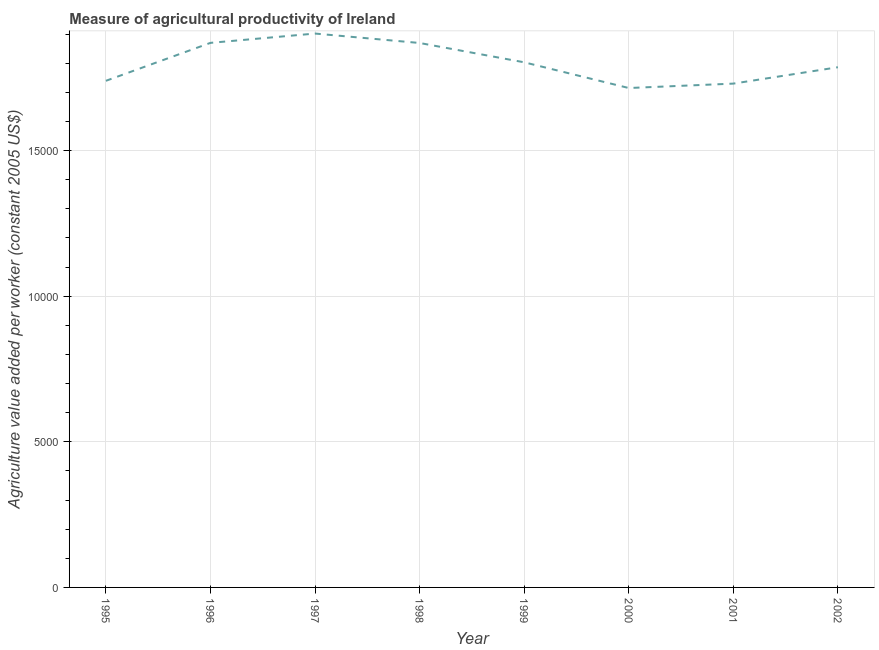What is the agriculture value added per worker in 2000?
Your answer should be compact. 1.71e+04. Across all years, what is the maximum agriculture value added per worker?
Offer a very short reply. 1.90e+04. Across all years, what is the minimum agriculture value added per worker?
Ensure brevity in your answer.  1.71e+04. What is the sum of the agriculture value added per worker?
Offer a very short reply. 1.44e+05. What is the difference between the agriculture value added per worker in 1996 and 2001?
Offer a very short reply. 1399.32. What is the average agriculture value added per worker per year?
Keep it short and to the point. 1.80e+04. What is the median agriculture value added per worker?
Give a very brief answer. 1.79e+04. In how many years, is the agriculture value added per worker greater than 4000 US$?
Offer a terse response. 8. What is the ratio of the agriculture value added per worker in 1996 to that in 1999?
Offer a very short reply. 1.04. Is the agriculture value added per worker in 1995 less than that in 2000?
Provide a succinct answer. No. What is the difference between the highest and the second highest agriculture value added per worker?
Your answer should be very brief. 319.78. Is the sum of the agriculture value added per worker in 2000 and 2002 greater than the maximum agriculture value added per worker across all years?
Offer a terse response. Yes. What is the difference between the highest and the lowest agriculture value added per worker?
Offer a terse response. 1870.44. Are the values on the major ticks of Y-axis written in scientific E-notation?
Ensure brevity in your answer.  No. Does the graph contain any zero values?
Provide a short and direct response. No. What is the title of the graph?
Provide a short and direct response. Measure of agricultural productivity of Ireland. What is the label or title of the X-axis?
Give a very brief answer. Year. What is the label or title of the Y-axis?
Your answer should be compact. Agriculture value added per worker (constant 2005 US$). What is the Agriculture value added per worker (constant 2005 US$) of 1995?
Give a very brief answer. 1.74e+04. What is the Agriculture value added per worker (constant 2005 US$) of 1996?
Ensure brevity in your answer.  1.87e+04. What is the Agriculture value added per worker (constant 2005 US$) in 1997?
Your answer should be very brief. 1.90e+04. What is the Agriculture value added per worker (constant 2005 US$) of 1998?
Your answer should be compact. 1.87e+04. What is the Agriculture value added per worker (constant 2005 US$) of 1999?
Ensure brevity in your answer.  1.80e+04. What is the Agriculture value added per worker (constant 2005 US$) in 2000?
Your response must be concise. 1.71e+04. What is the Agriculture value added per worker (constant 2005 US$) in 2001?
Your answer should be compact. 1.73e+04. What is the Agriculture value added per worker (constant 2005 US$) of 2002?
Offer a terse response. 1.79e+04. What is the difference between the Agriculture value added per worker (constant 2005 US$) in 1995 and 1996?
Your answer should be compact. -1303.08. What is the difference between the Agriculture value added per worker (constant 2005 US$) in 1995 and 1997?
Make the answer very short. -1622.86. What is the difference between the Agriculture value added per worker (constant 2005 US$) in 1995 and 1998?
Make the answer very short. -1298.7. What is the difference between the Agriculture value added per worker (constant 2005 US$) in 1995 and 1999?
Your answer should be compact. -635.52. What is the difference between the Agriculture value added per worker (constant 2005 US$) in 1995 and 2000?
Offer a terse response. 247.58. What is the difference between the Agriculture value added per worker (constant 2005 US$) in 1995 and 2001?
Your answer should be compact. 96.24. What is the difference between the Agriculture value added per worker (constant 2005 US$) in 1995 and 2002?
Give a very brief answer. -466.16. What is the difference between the Agriculture value added per worker (constant 2005 US$) in 1996 and 1997?
Keep it short and to the point. -319.78. What is the difference between the Agriculture value added per worker (constant 2005 US$) in 1996 and 1998?
Your answer should be compact. 4.38. What is the difference between the Agriculture value added per worker (constant 2005 US$) in 1996 and 1999?
Give a very brief answer. 667.56. What is the difference between the Agriculture value added per worker (constant 2005 US$) in 1996 and 2000?
Keep it short and to the point. 1550.66. What is the difference between the Agriculture value added per worker (constant 2005 US$) in 1996 and 2001?
Make the answer very short. 1399.32. What is the difference between the Agriculture value added per worker (constant 2005 US$) in 1996 and 2002?
Your response must be concise. 836.92. What is the difference between the Agriculture value added per worker (constant 2005 US$) in 1997 and 1998?
Provide a short and direct response. 324.17. What is the difference between the Agriculture value added per worker (constant 2005 US$) in 1997 and 1999?
Give a very brief answer. 987.34. What is the difference between the Agriculture value added per worker (constant 2005 US$) in 1997 and 2000?
Provide a succinct answer. 1870.44. What is the difference between the Agriculture value added per worker (constant 2005 US$) in 1997 and 2001?
Your answer should be compact. 1719.1. What is the difference between the Agriculture value added per worker (constant 2005 US$) in 1997 and 2002?
Provide a succinct answer. 1156.7. What is the difference between the Agriculture value added per worker (constant 2005 US$) in 1998 and 1999?
Offer a very short reply. 663.18. What is the difference between the Agriculture value added per worker (constant 2005 US$) in 1998 and 2000?
Make the answer very short. 1546.27. What is the difference between the Agriculture value added per worker (constant 2005 US$) in 1998 and 2001?
Your response must be concise. 1394.93. What is the difference between the Agriculture value added per worker (constant 2005 US$) in 1998 and 2002?
Your response must be concise. 832.54. What is the difference between the Agriculture value added per worker (constant 2005 US$) in 1999 and 2000?
Offer a terse response. 883.1. What is the difference between the Agriculture value added per worker (constant 2005 US$) in 1999 and 2001?
Keep it short and to the point. 731.76. What is the difference between the Agriculture value added per worker (constant 2005 US$) in 1999 and 2002?
Your answer should be very brief. 169.36. What is the difference between the Agriculture value added per worker (constant 2005 US$) in 2000 and 2001?
Offer a terse response. -151.34. What is the difference between the Agriculture value added per worker (constant 2005 US$) in 2000 and 2002?
Your response must be concise. -713.73. What is the difference between the Agriculture value added per worker (constant 2005 US$) in 2001 and 2002?
Make the answer very short. -562.4. What is the ratio of the Agriculture value added per worker (constant 2005 US$) in 1995 to that in 1996?
Your answer should be very brief. 0.93. What is the ratio of the Agriculture value added per worker (constant 2005 US$) in 1995 to that in 1997?
Offer a terse response. 0.92. What is the ratio of the Agriculture value added per worker (constant 2005 US$) in 1995 to that in 1999?
Provide a succinct answer. 0.96. What is the ratio of the Agriculture value added per worker (constant 2005 US$) in 1995 to that in 2000?
Your answer should be compact. 1.01. What is the ratio of the Agriculture value added per worker (constant 2005 US$) in 1995 to that in 2001?
Make the answer very short. 1.01. What is the ratio of the Agriculture value added per worker (constant 2005 US$) in 1996 to that in 1998?
Your response must be concise. 1. What is the ratio of the Agriculture value added per worker (constant 2005 US$) in 1996 to that in 2000?
Provide a succinct answer. 1.09. What is the ratio of the Agriculture value added per worker (constant 2005 US$) in 1996 to that in 2001?
Offer a very short reply. 1.08. What is the ratio of the Agriculture value added per worker (constant 2005 US$) in 1996 to that in 2002?
Offer a very short reply. 1.05. What is the ratio of the Agriculture value added per worker (constant 2005 US$) in 1997 to that in 1998?
Keep it short and to the point. 1.02. What is the ratio of the Agriculture value added per worker (constant 2005 US$) in 1997 to that in 1999?
Make the answer very short. 1.05. What is the ratio of the Agriculture value added per worker (constant 2005 US$) in 1997 to that in 2000?
Make the answer very short. 1.11. What is the ratio of the Agriculture value added per worker (constant 2005 US$) in 1997 to that in 2001?
Provide a short and direct response. 1.1. What is the ratio of the Agriculture value added per worker (constant 2005 US$) in 1997 to that in 2002?
Keep it short and to the point. 1.06. What is the ratio of the Agriculture value added per worker (constant 2005 US$) in 1998 to that in 1999?
Give a very brief answer. 1.04. What is the ratio of the Agriculture value added per worker (constant 2005 US$) in 1998 to that in 2000?
Provide a succinct answer. 1.09. What is the ratio of the Agriculture value added per worker (constant 2005 US$) in 1998 to that in 2001?
Keep it short and to the point. 1.08. What is the ratio of the Agriculture value added per worker (constant 2005 US$) in 1998 to that in 2002?
Ensure brevity in your answer.  1.05. What is the ratio of the Agriculture value added per worker (constant 2005 US$) in 1999 to that in 2000?
Your answer should be very brief. 1.05. What is the ratio of the Agriculture value added per worker (constant 2005 US$) in 1999 to that in 2001?
Offer a very short reply. 1.04. What is the ratio of the Agriculture value added per worker (constant 2005 US$) in 2000 to that in 2001?
Ensure brevity in your answer.  0.99. 